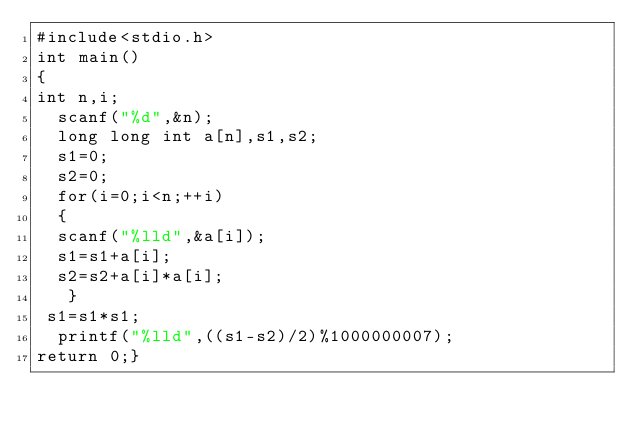<code> <loc_0><loc_0><loc_500><loc_500><_C_>#include<stdio.h>
int main()
{
int n,i;
  scanf("%d",&n);
  long long int a[n],s1,s2;
  s1=0;
  s2=0;
  for(i=0;i<n;++i)
  {
  scanf("%lld",&a[i]);
  s1=s1+a[i];
  s2=s2+a[i]*a[i];
   }
 s1=s1*s1;
  printf("%lld",((s1-s2)/2)%1000000007);
return 0;}</code> 